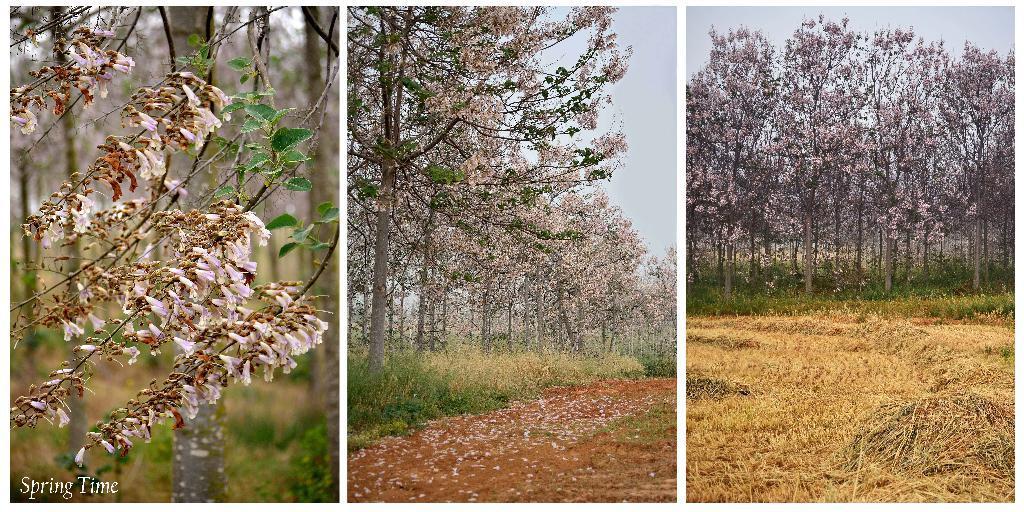In one or two sentences, can you explain what this image depicts? In this picture we can see three frames. On the right we can see many trees and grass. In the center we can see trees, flowers and grass. On the left we can see flowers leaves, branches and trees. Here it's a sky. 